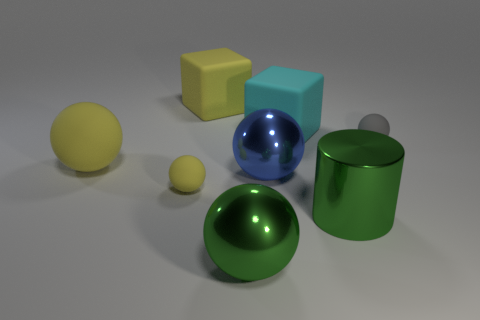Is the number of tiny things behind the tiny yellow sphere greater than the number of yellow things that are behind the yellow cube?
Provide a succinct answer. Yes. What is the color of the large ball that is in front of the tiny yellow object?
Offer a terse response. Green. Are there any large things of the same shape as the tiny gray matte thing?
Give a very brief answer. Yes. How many purple things are either small rubber things or big balls?
Your response must be concise. 0. Is there another blue metallic sphere that has the same size as the blue shiny ball?
Your answer should be very brief. No. What number of big blue shiny spheres are there?
Your response must be concise. 1. How many small objects are either red shiny cylinders or blue objects?
Provide a short and direct response. 0. There is a small matte ball right of the tiny rubber thing that is to the left of the shiny ball in front of the large shiny cylinder; what color is it?
Your response must be concise. Gray. How many other things are there of the same color as the metal cylinder?
Ensure brevity in your answer.  1. What number of rubber objects are either yellow blocks or tiny yellow objects?
Ensure brevity in your answer.  2. 